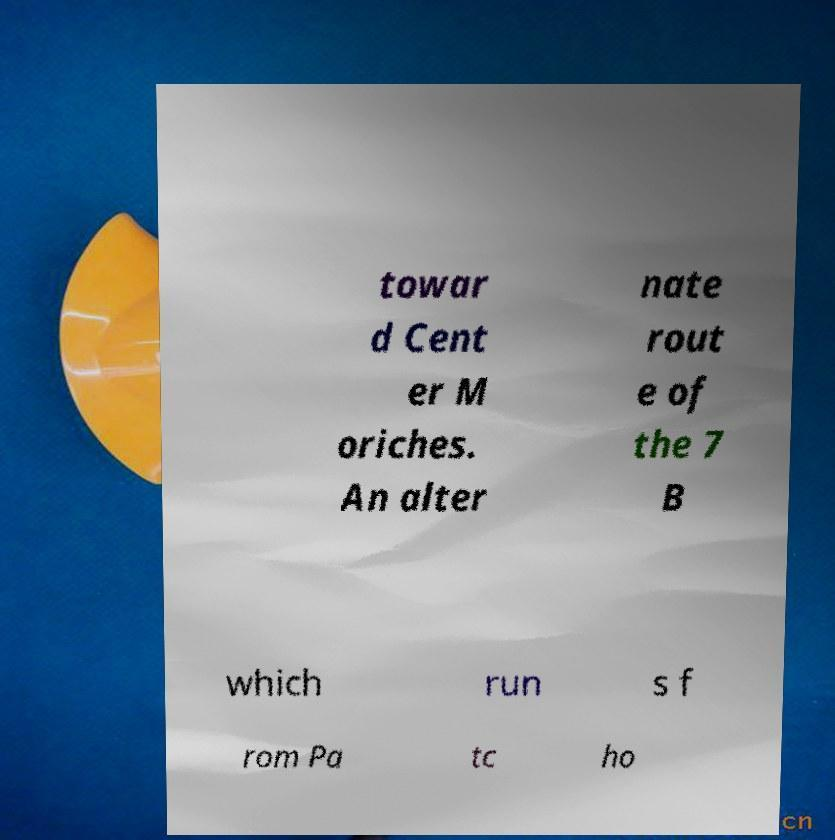There's text embedded in this image that I need extracted. Can you transcribe it verbatim? towar d Cent er M oriches. An alter nate rout e of the 7 B which run s f rom Pa tc ho 